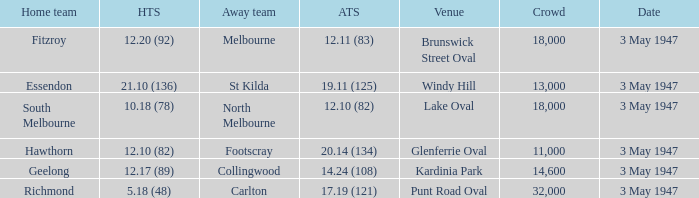In the game where the away team score is 17.19 (121), who was the away team? Carlton. 